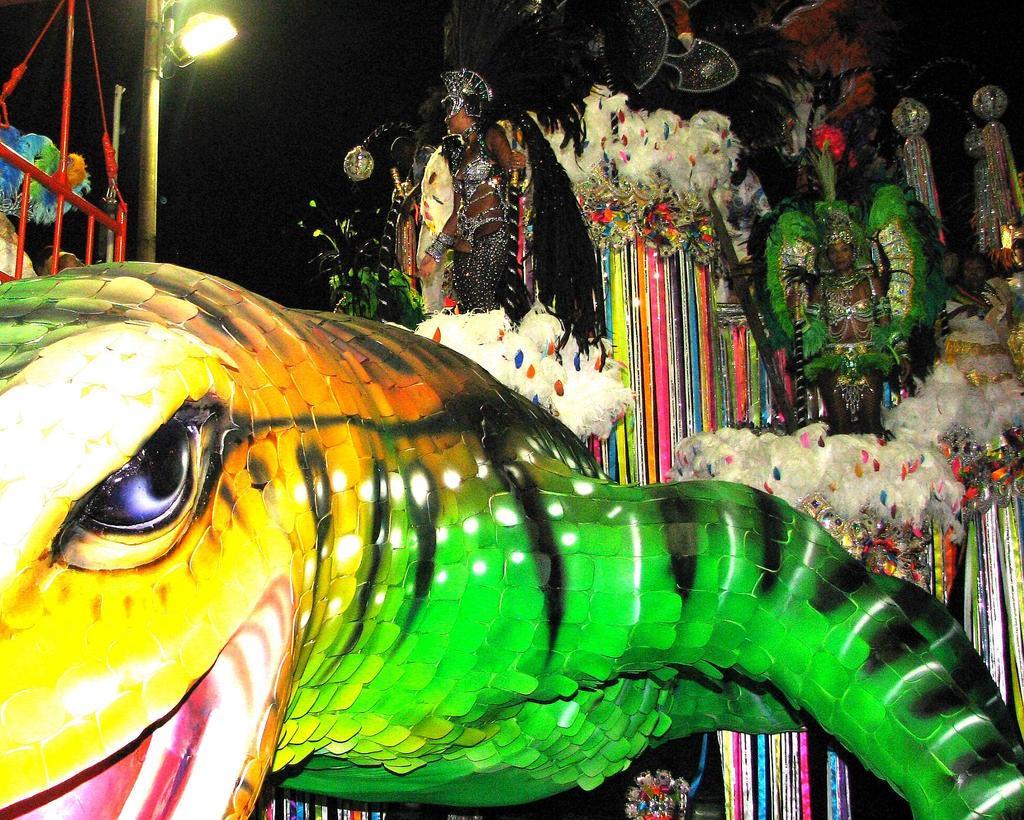Can you describe this image briefly? At the bottom of the image we can see a doll. In the middle of the image few people are standing and there is a pole, on the pole there is a light. 